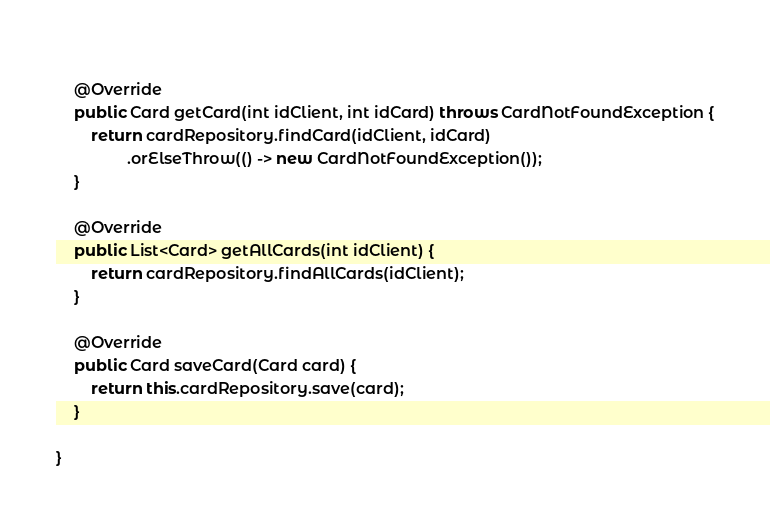<code> <loc_0><loc_0><loc_500><loc_500><_Java_>	
	@Override
	public Card getCard(int idClient, int idCard) throws CardNotFoundException {
		return cardRepository.findCard(idClient, idCard)
				.orElseThrow(() -> new CardNotFoundException());
	}

	@Override
	public List<Card> getAllCards(int idClient) {
		return cardRepository.findAllCards(idClient);
	}
	
	@Override
	public Card saveCard(Card card) {
		return this.cardRepository.save(card);
	}

}
</code> 